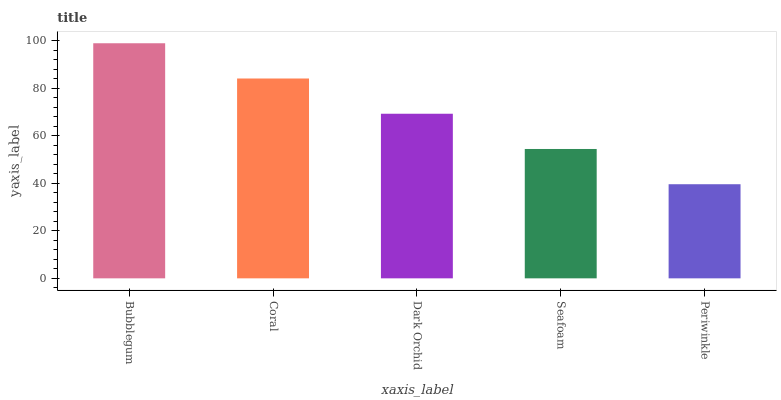Is Periwinkle the minimum?
Answer yes or no. Yes. Is Bubblegum the maximum?
Answer yes or no. Yes. Is Coral the minimum?
Answer yes or no. No. Is Coral the maximum?
Answer yes or no. No. Is Bubblegum greater than Coral?
Answer yes or no. Yes. Is Coral less than Bubblegum?
Answer yes or no. Yes. Is Coral greater than Bubblegum?
Answer yes or no. No. Is Bubblegum less than Coral?
Answer yes or no. No. Is Dark Orchid the high median?
Answer yes or no. Yes. Is Dark Orchid the low median?
Answer yes or no. Yes. Is Bubblegum the high median?
Answer yes or no. No. Is Coral the low median?
Answer yes or no. No. 